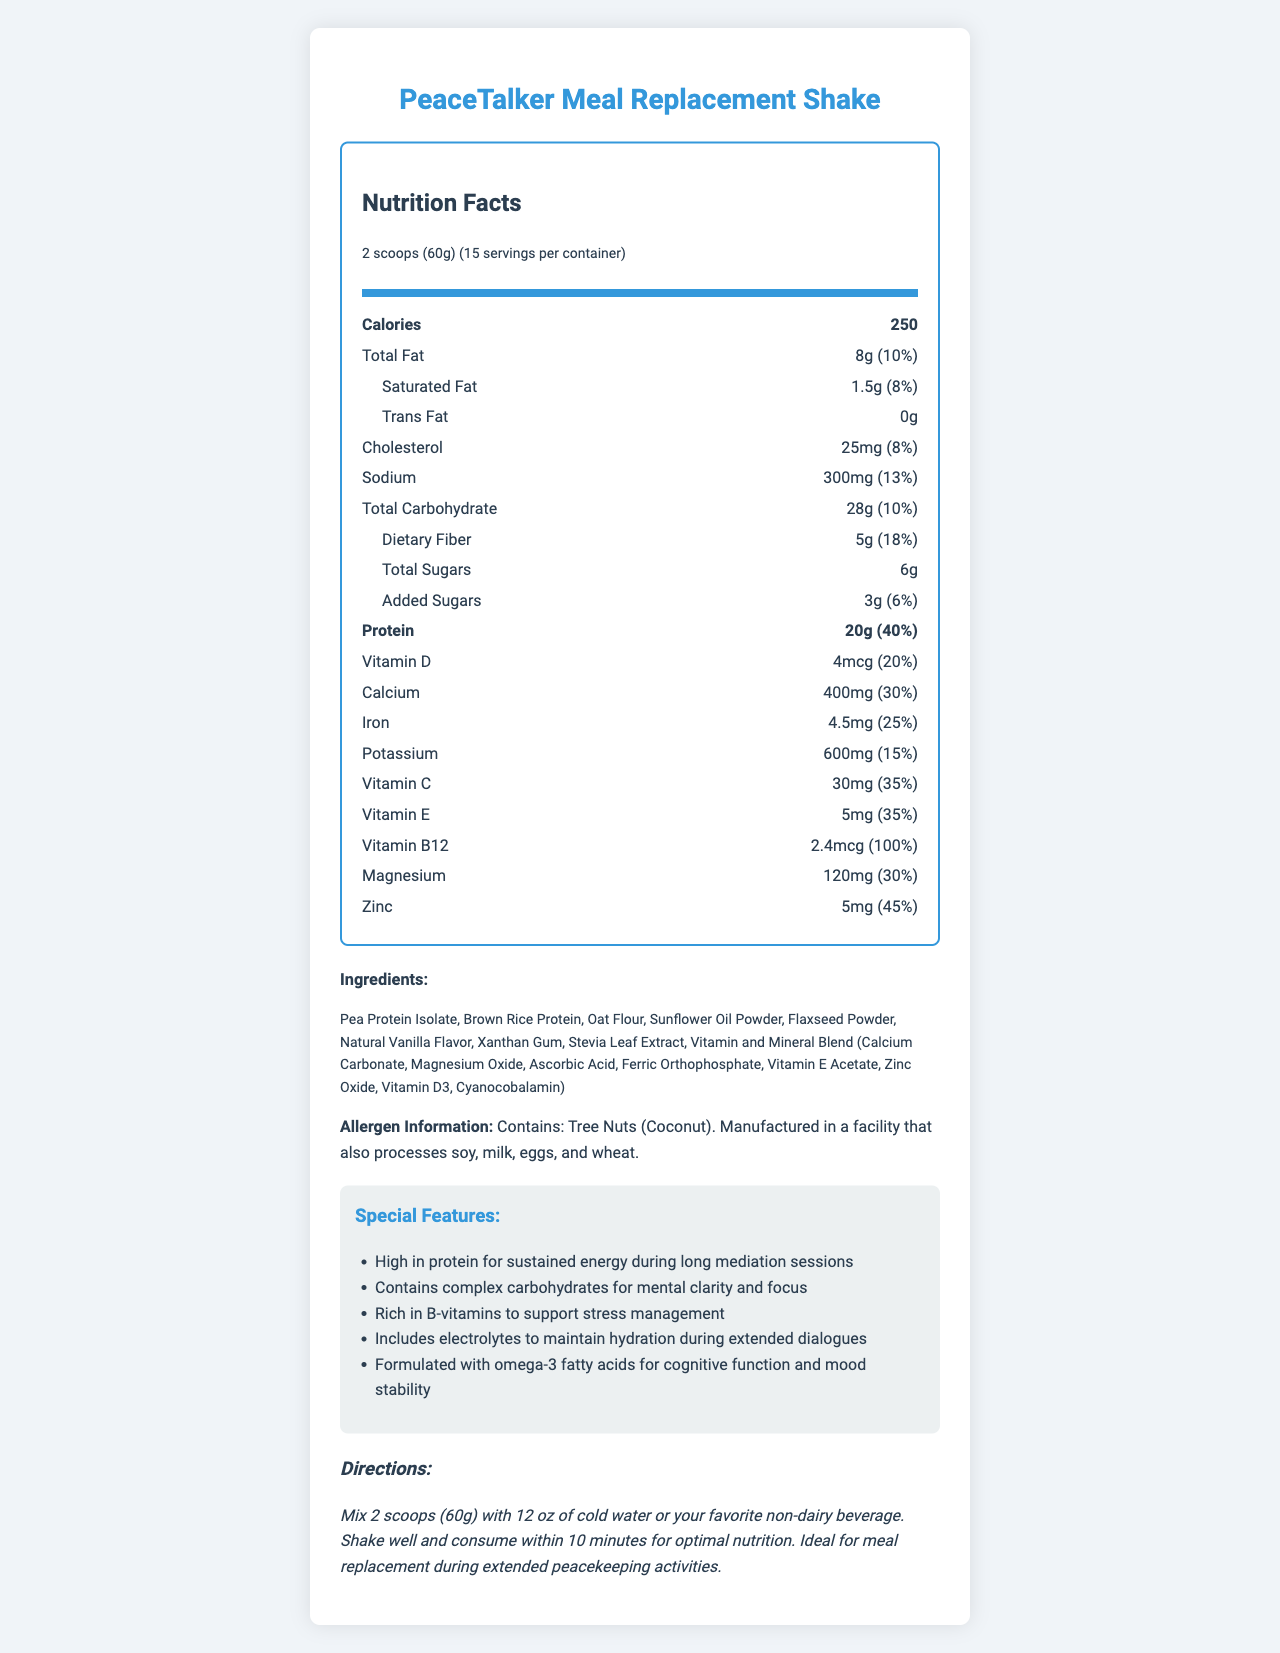what is the serving size of PeaceTalker Meal Replacement Shake? The serving size is mentioned at the top of the Nutrition Facts section indicating "2 scoops (60g)."
Answer: 2 scoops (60g) how many servings are in one container of the shake? The document states there are "15 servings per container."
Answer: 15 what is the total fat content per serving? The total fat content per serving is listed as 8g, which is 10% of the daily value.
Answer: 8g (10%) how much protein does one serving contain? The amount of protein per serving is 20g, which is 40% of the daily value.
Answer: 20g (40%) what special feature helps support stress management? One of the special features listed is "Rich in B-vitamins to support stress management."
Answer: Rich in B-vitamins how much added sugars are there in one serving? The document states that there are 3g of added sugars per serving, which is 6% of the daily value.
Answer: 3g (6%) which vitamin has the highest daily value percentage in one serving? A. Vitamin D B. Vitamin C C. Vitamin B12 D. Vitamin E Vitamin B12 has a daily value of 100%, while Vitamin D is 20%, Vitamin C is 35%, and Vitamin E is 35%.
Answer: C. Vitamin B12 how many calories are there per serving of the PeaceTalker Meal Replacement Shake? A. 150 B. 200 C. 250 D. 300 The document lists the calorie count per serving as 250.
Answer: C. 250 does the shake contain any tree nuts? The allergen information mentions, "Contains: Tree Nuts (Coconut)."
Answer: Yes is the shake suitable for individuals with lactose intolerance? The document mentions it is manufactured in a facility that processes milk but does not specify if the shake itself contains lactose.
Answer: Not enough information summarize the main features of the PeaceTalker Meal Replacement Shake. The main aspects covered are its nutritional composition, intended benefits, key ingredients, allergen information, and preparation instructions.
Answer: The PeaceTalker Meal Replacement Shake is a high-protein, nutrient-dense shake designed for sustained energy and mental clarity during extended periods of dialogue and mediation. Each serving contains 250 calories, 8g of total fat, 20g of protein, and various vitamins and minerals. It includes ingredients like Pea Protein Isolate and Brown Rice Protein, and is designed with special features such as complex carbohydrates for mental focus, and B-vitamins for stress management. It also contains electrolytes for hydration and omega-3 fatty acids for cognitive function and mood stability. It includes an allergen warning for tree nuts and is made in a facility that processes common allergens. The shake is easy to prepare by mixing with water or a non-dairy beverage. 